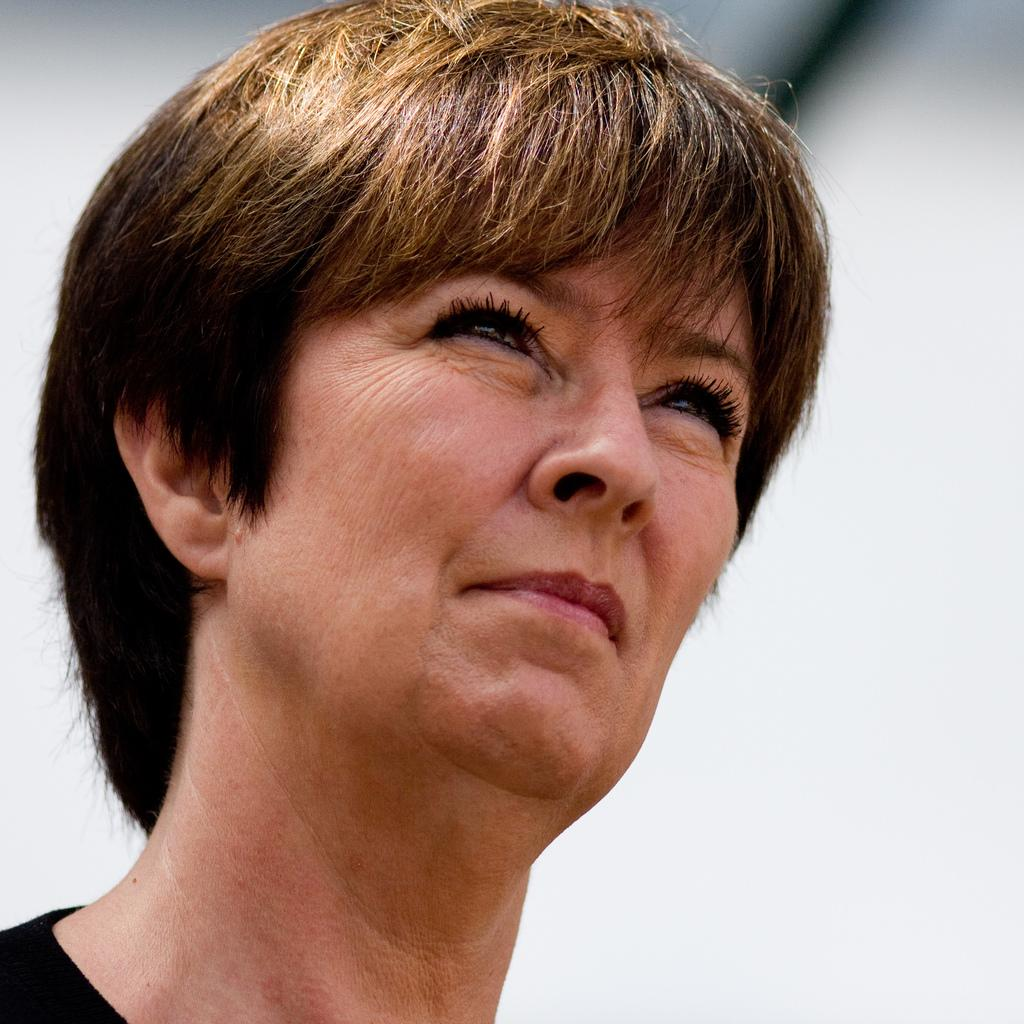Who or what is the main subject of the image? There is a person in the image. What color is the background of the image? The background of the image is white. Can you describe the object at the top of the image? Unfortunately, the provided facts do not give any information about the object at the top of the image. What type of ink is being used by the person in the image? There is no mention of ink in the provided facts. 